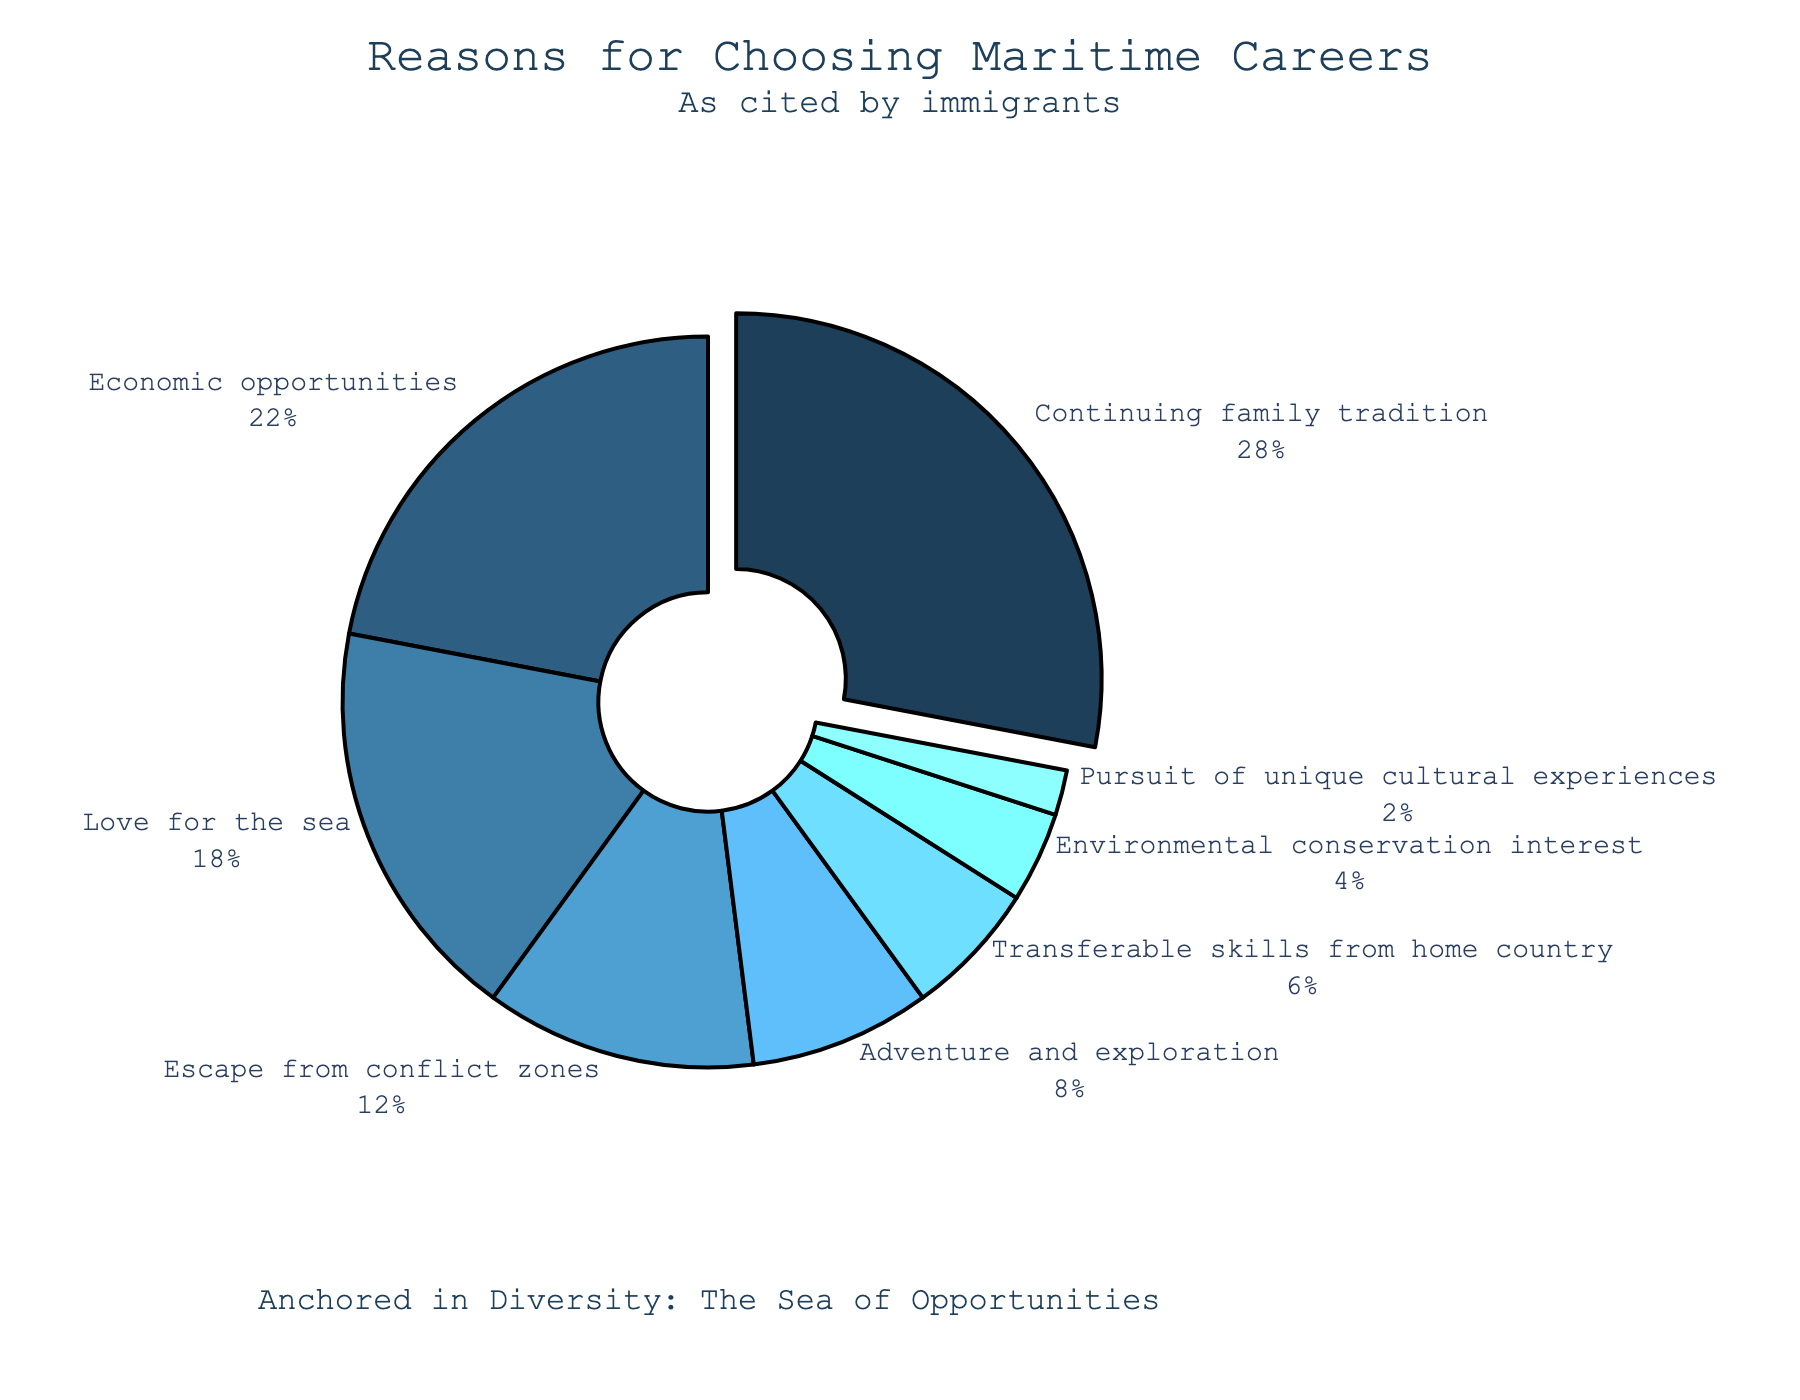Which reason has the highest percentage for choosing maritime careers? The slice representing "Continuing family tradition" is pulled out slightly, indicating it has the highest percentage. The percentage label shows 28%.
Answer: Continuing family tradition What is the total percentage of immigrants citing "Economic opportunities" and "Love for the sea"? The pie chart shows that "Economic opportunities" is 22% and "Love for the sea" is 18%. Adding these percentages gives 22% + 18% = 40%.
Answer: 40% How much larger is the percentage for "Continuing family tradition" compared to "Adventure and exploration"? "Continuing family tradition" is 28% and "Adventure and exploration" is 8%. The difference is 28% - 8% = 20%.
Answer: 20% Which percent is smaller: "Escape from conflict zones" or "Transferable skills from home country"? The pie chart shows that "Escape from conflict zones" is 12% and "Transferable skills from home country" is 6%. 12% is larger, so "Transferable skills from home country" is smaller.
Answer: Transferable skills from home country If we combine the reasons "Environmental conservation interest" and "Pursuit of unique cultural experiences", what would be their total percentage? "Environmental conservation interest" is 4% and "Pursuit of unique cultural experiences" is 2%. Adding these percentages gives 4% + 2% = 6%.
Answer: 6% Rank the top three reasons provided by immigrants for choosing maritime careers. The top three slices by percentage are "Continuing family tradition" (28%), "Economic opportunities" (22%), and "Love for the sea" (18%).
Answer: Continuing family tradition, Economic opportunities, Love for the sea Which reason cited by immigrants has a percentage that is exactly half of "Love for the sea"? "Love for the sea" has a percentage of 18%. Half of 18% is 9%. The closest reason to 9% is "Adventure and exploration" at 8%.
Answer: Adventure and exploration What is the combined percentage of all reasons excluding the one with the highest percentage? The highest percentage is "Continuing family tradition" at 28%. The total for all reasons is 100%. Subtracting 28% from 100% gives 72%.
Answer: 72% 